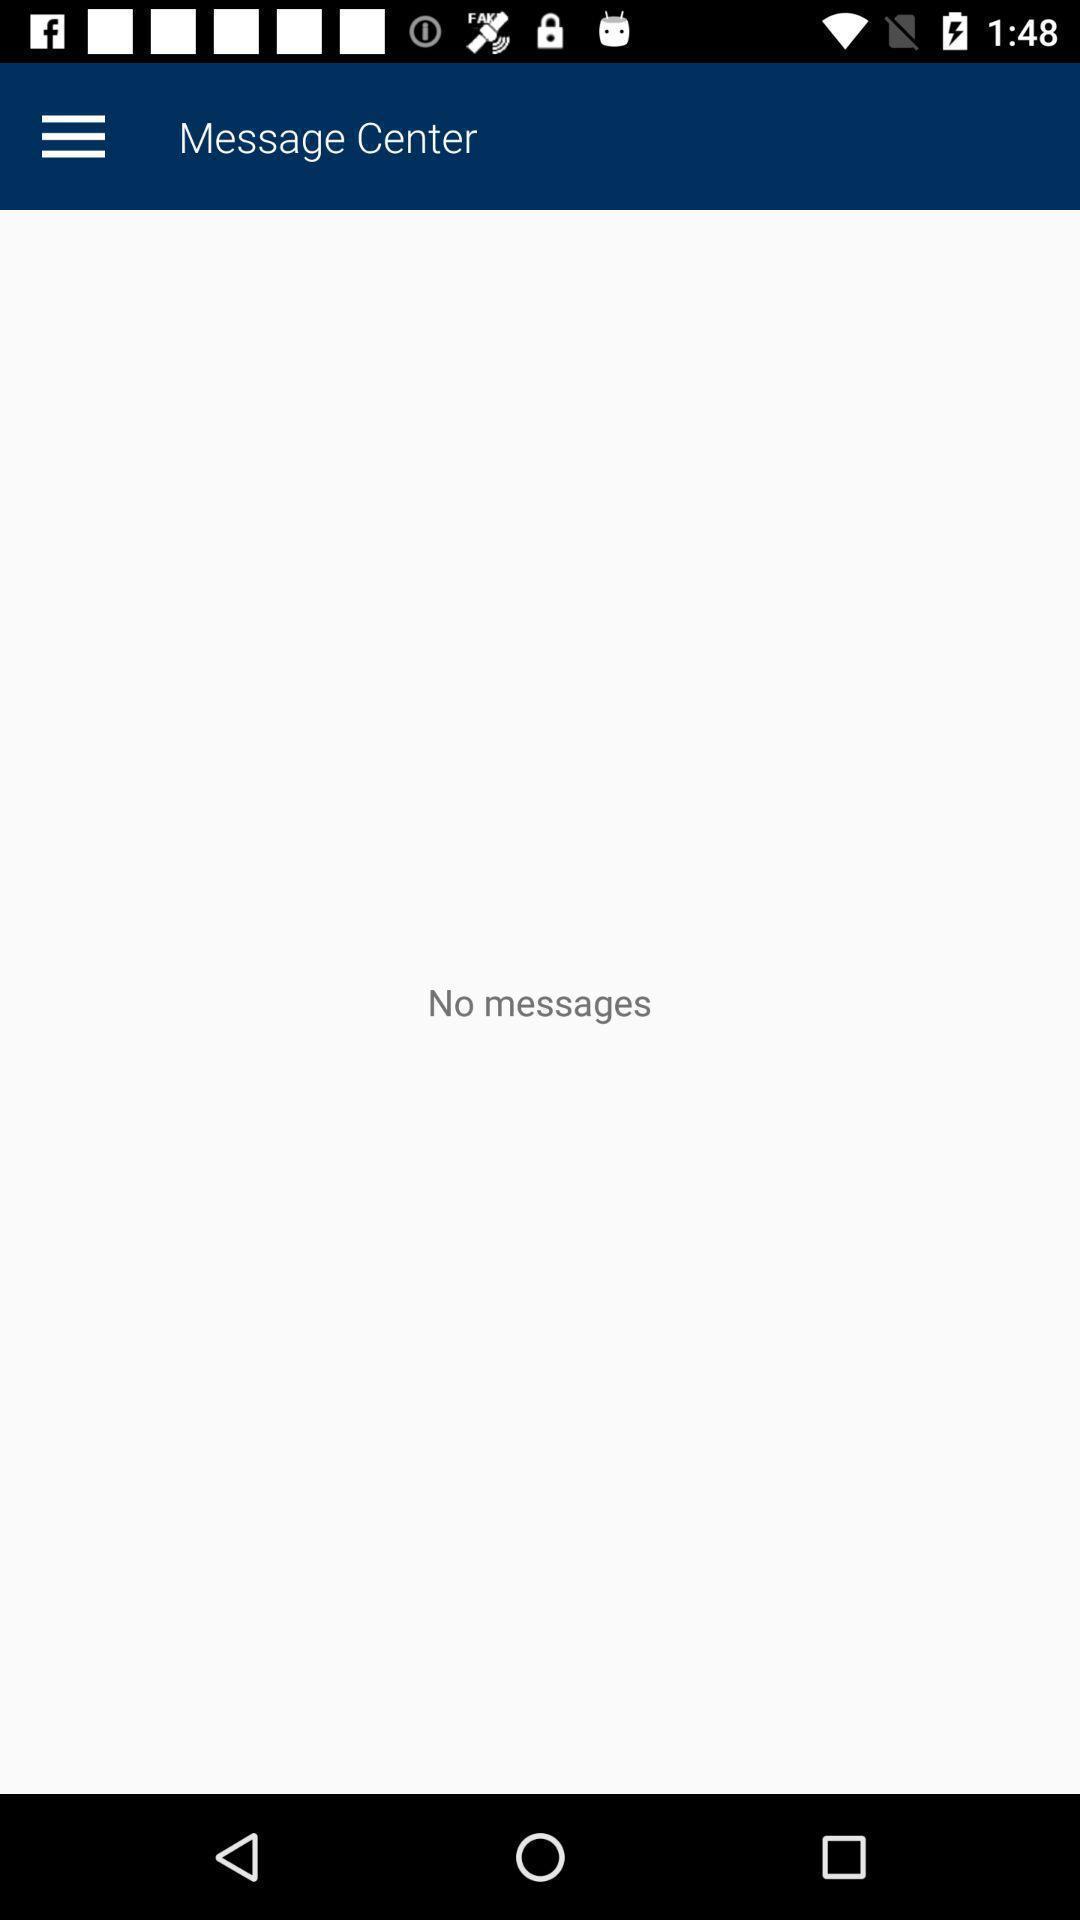Give me a summary of this screen capture. Window displaying a message center page. 